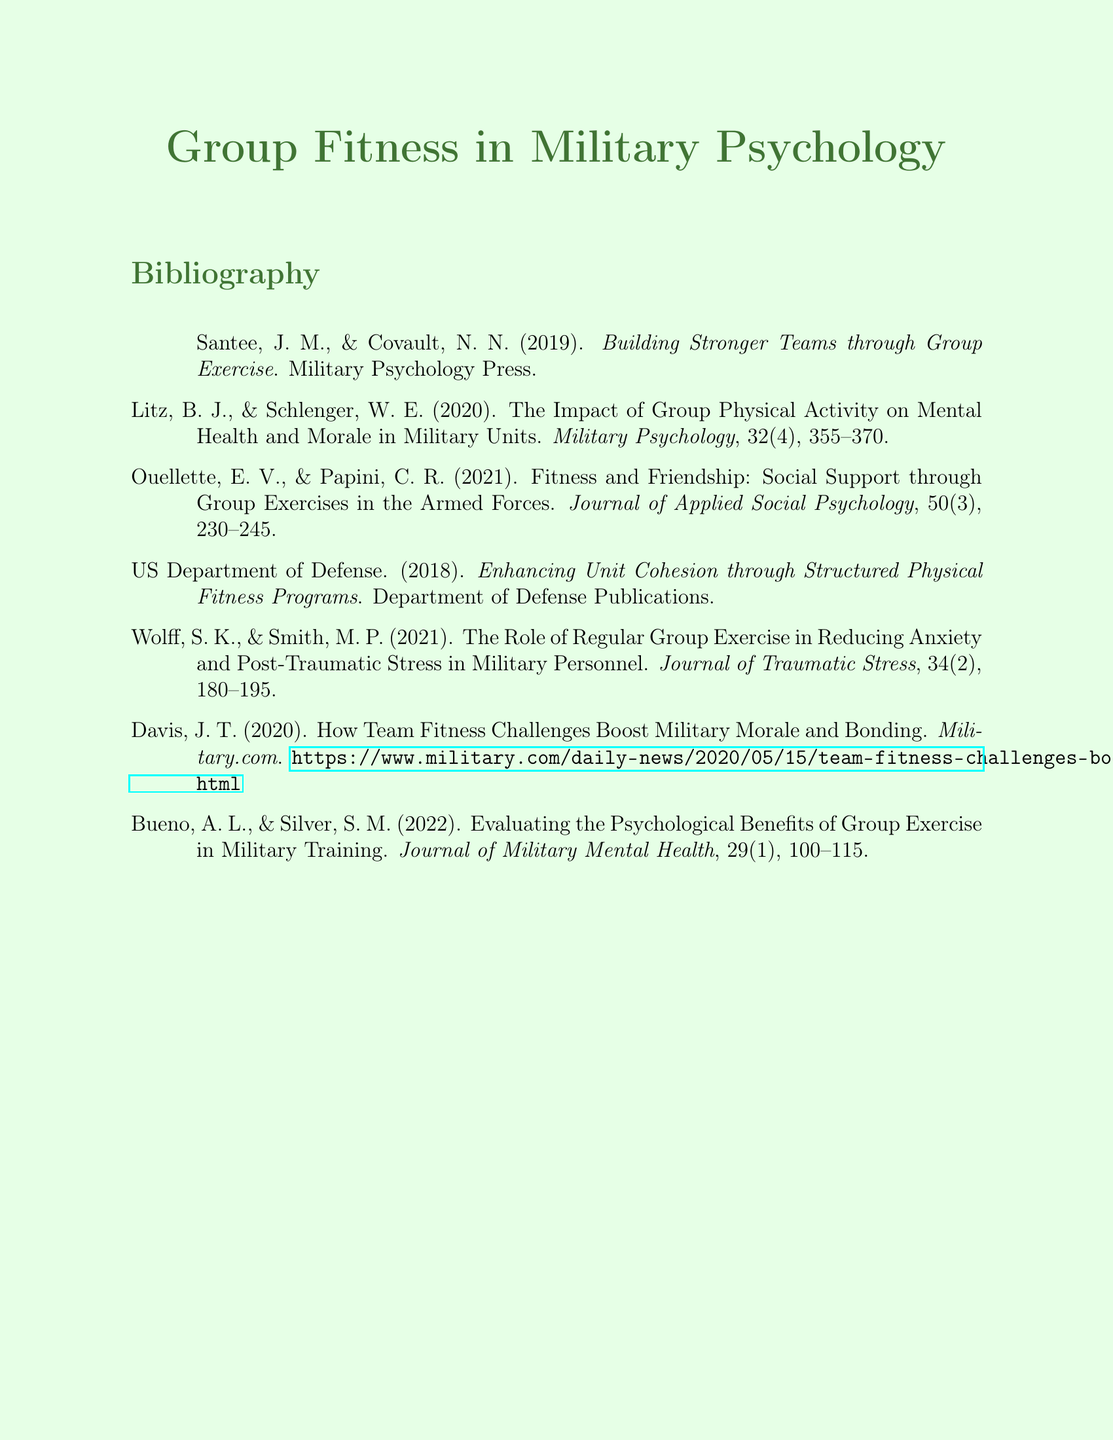What is the title of the document? The title of the document is presented as the heading at the top: "Group Fitness in Military Psychology."
Answer: Group Fitness in Military Psychology Who are the authors of the first reference? The first reference lists the authors as Santee and Covault.
Answer: Santee, J. M., & Covault, N. N What year was the reference by Litz published? The year of publication for the reference by Litz is noted in the citation.
Answer: 2020 Which journal published the article by Ouellette? The journal that published the article by Ouellette is specified in the citation.
Answer: Journal of Applied Social Psychology What is the main focus of the document's bibliography? The bibliography focuses on various aspects of group fitness activities in military settings.
Answer: Group fitness activities in military settings How many pages does the article by Wolff cover? The citation indicates the article spans from page 180 to page 195.
Answer: 16 pages What type of publication is referenced by the US Department of Defense? The US Department of Defense reference is categorized as a publication.
Answer: Department of Defense Publications What is the topic of the article by Davis? The article by Davis discusses the benefits of team fitness challenges.
Answer: Team fitness challenges 